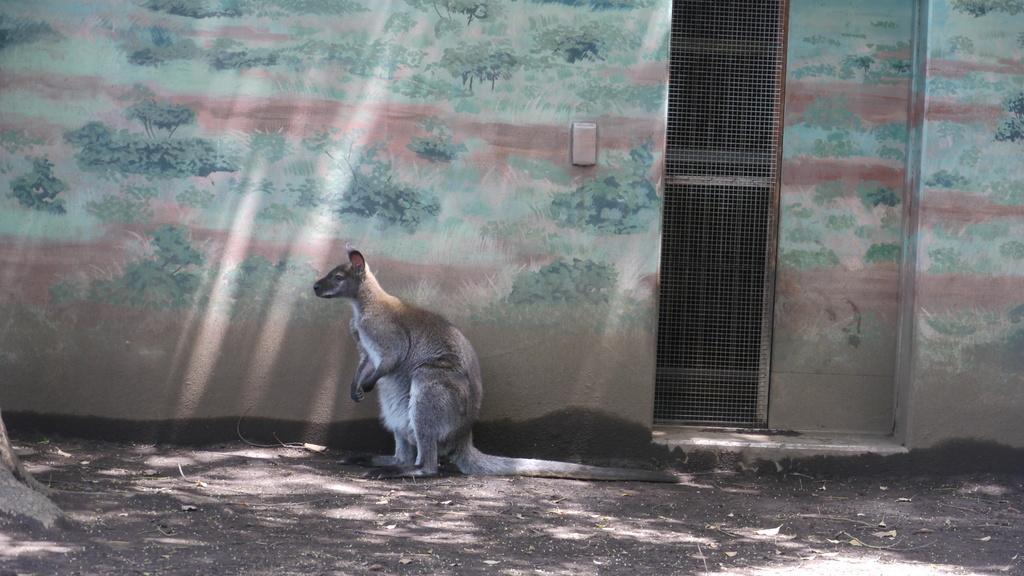What animal is standing in the image? There is a kangaroo standing in the image. What type of artwork is the kangaroo in? The image appears to be a wall painting on a building wall. What else can be seen in the image besides the kangaroo? There is a fence sheet visible in the image. What degree does the kangaroo have in the image? The kangaroo is not a person and therefore cannot have a degree. Additionally, the image is a wall painting and not a real-life scenario. 